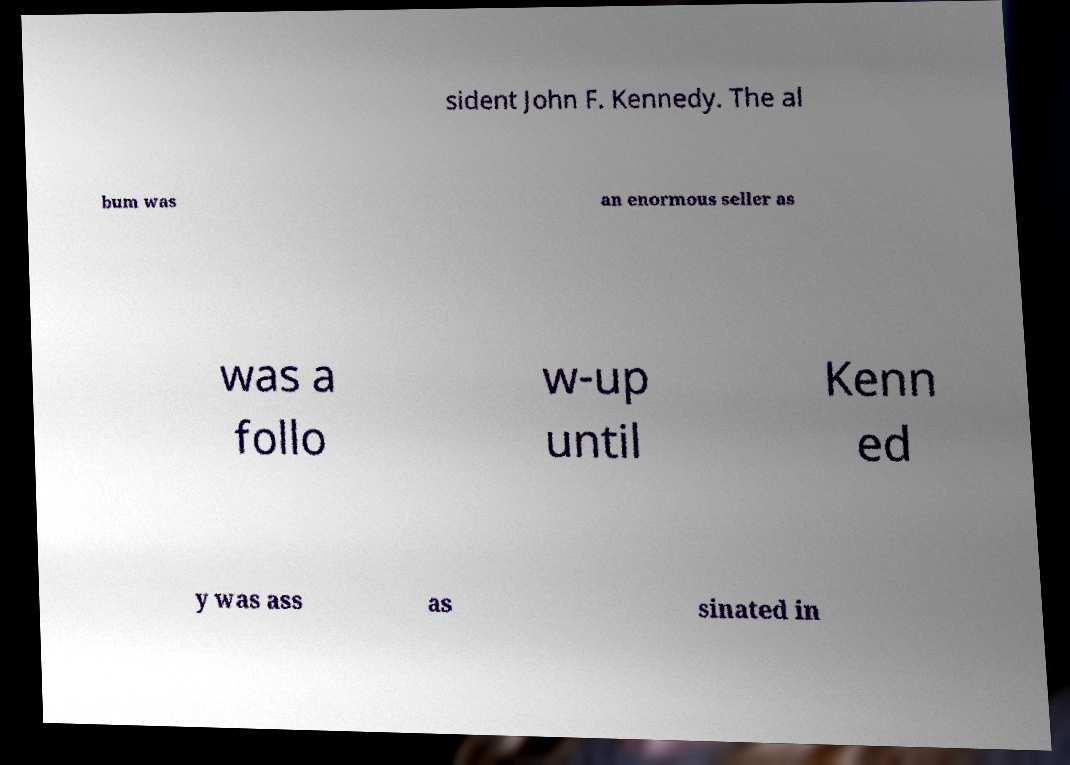What messages or text are displayed in this image? I need them in a readable, typed format. sident John F. Kennedy. The al bum was an enormous seller as was a follo w-up until Kenn ed y was ass as sinated in 